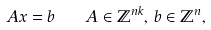<formula> <loc_0><loc_0><loc_500><loc_500>A x = b \quad A \in \mathbb { Z } ^ { n k } , \, b \in \mathbb { Z } ^ { n } ,</formula> 